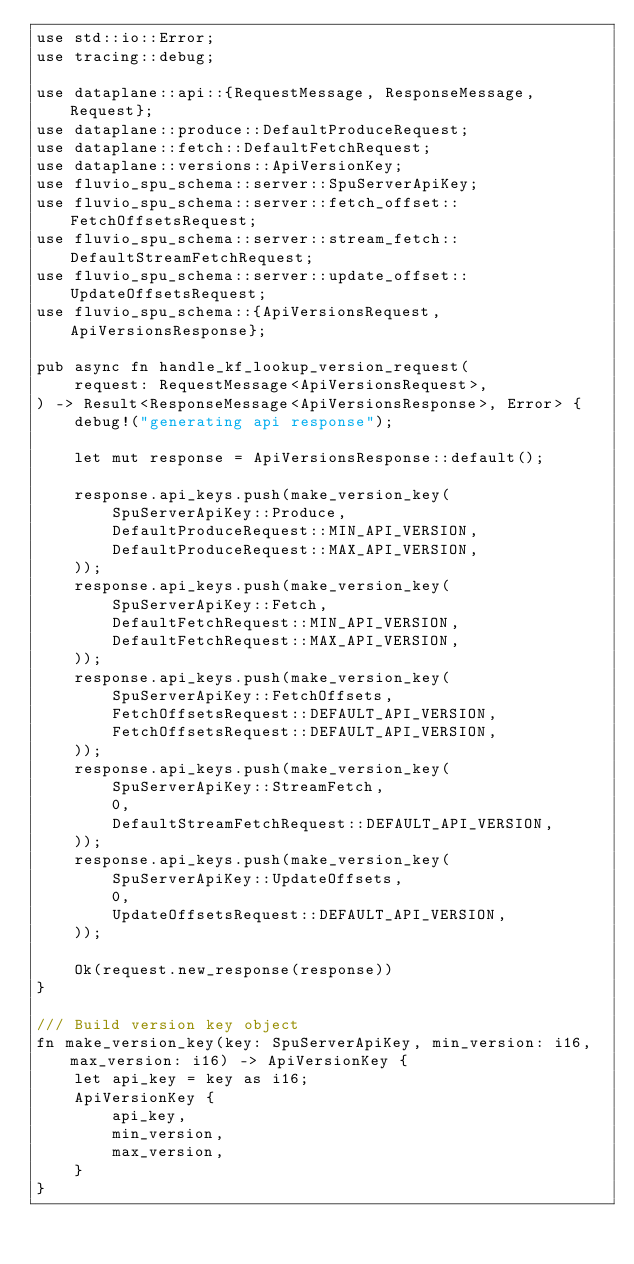<code> <loc_0><loc_0><loc_500><loc_500><_Rust_>use std::io::Error;
use tracing::debug;

use dataplane::api::{RequestMessage, ResponseMessage, Request};
use dataplane::produce::DefaultProduceRequest;
use dataplane::fetch::DefaultFetchRequest;
use dataplane::versions::ApiVersionKey;
use fluvio_spu_schema::server::SpuServerApiKey;
use fluvio_spu_schema::server::fetch_offset::FetchOffsetsRequest;
use fluvio_spu_schema::server::stream_fetch::DefaultStreamFetchRequest;
use fluvio_spu_schema::server::update_offset::UpdateOffsetsRequest;
use fluvio_spu_schema::{ApiVersionsRequest, ApiVersionsResponse};

pub async fn handle_kf_lookup_version_request(
    request: RequestMessage<ApiVersionsRequest>,
) -> Result<ResponseMessage<ApiVersionsResponse>, Error> {
    debug!("generating api response");

    let mut response = ApiVersionsResponse::default();

    response.api_keys.push(make_version_key(
        SpuServerApiKey::Produce,
        DefaultProduceRequest::MIN_API_VERSION,
        DefaultProduceRequest::MAX_API_VERSION,
    ));
    response.api_keys.push(make_version_key(
        SpuServerApiKey::Fetch,
        DefaultFetchRequest::MIN_API_VERSION,
        DefaultFetchRequest::MAX_API_VERSION,
    ));
    response.api_keys.push(make_version_key(
        SpuServerApiKey::FetchOffsets,
        FetchOffsetsRequest::DEFAULT_API_VERSION,
        FetchOffsetsRequest::DEFAULT_API_VERSION,
    ));
    response.api_keys.push(make_version_key(
        SpuServerApiKey::StreamFetch,
        0,
        DefaultStreamFetchRequest::DEFAULT_API_VERSION,
    ));
    response.api_keys.push(make_version_key(
        SpuServerApiKey::UpdateOffsets,
        0,
        UpdateOffsetsRequest::DEFAULT_API_VERSION,
    ));

    Ok(request.new_response(response))
}

/// Build version key object
fn make_version_key(key: SpuServerApiKey, min_version: i16, max_version: i16) -> ApiVersionKey {
    let api_key = key as i16;
    ApiVersionKey {
        api_key,
        min_version,
        max_version,
    }
}
</code> 